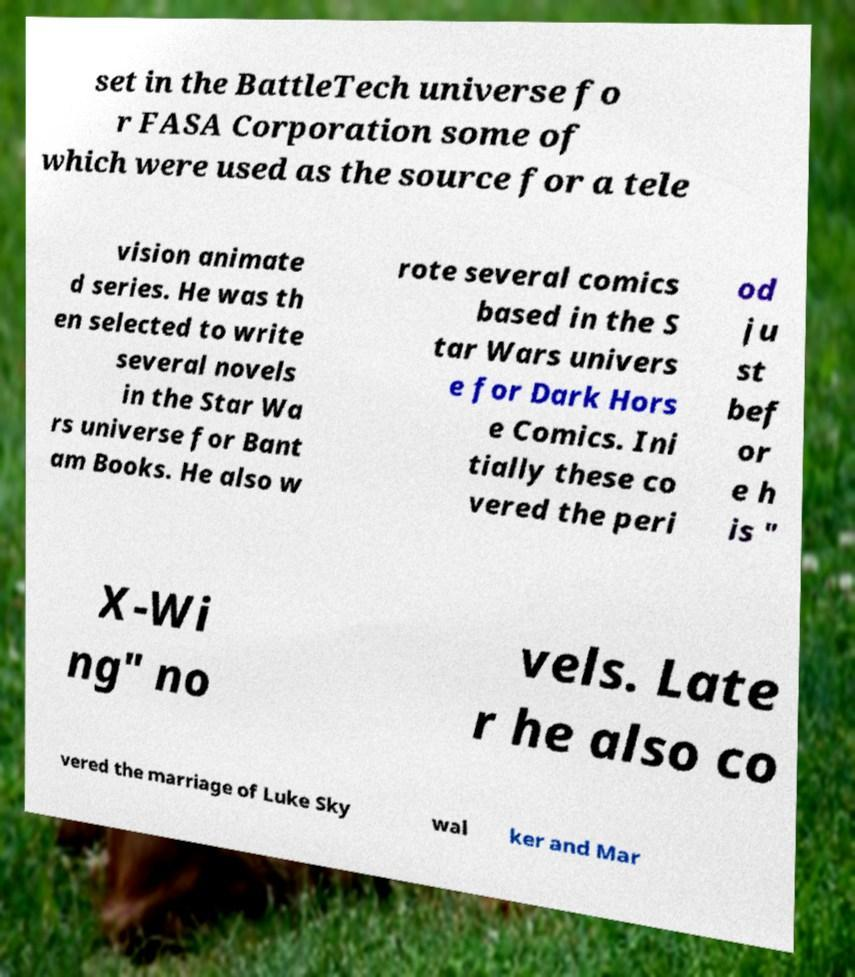There's text embedded in this image that I need extracted. Can you transcribe it verbatim? set in the BattleTech universe fo r FASA Corporation some of which were used as the source for a tele vision animate d series. He was th en selected to write several novels in the Star Wa rs universe for Bant am Books. He also w rote several comics based in the S tar Wars univers e for Dark Hors e Comics. Ini tially these co vered the peri od ju st bef or e h is " X-Wi ng" no vels. Late r he also co vered the marriage of Luke Sky wal ker and Mar 